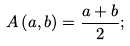Convert formula to latex. <formula><loc_0><loc_0><loc_500><loc_500>A \left ( a , b \right ) = \frac { a + b } { 2 } ;</formula> 